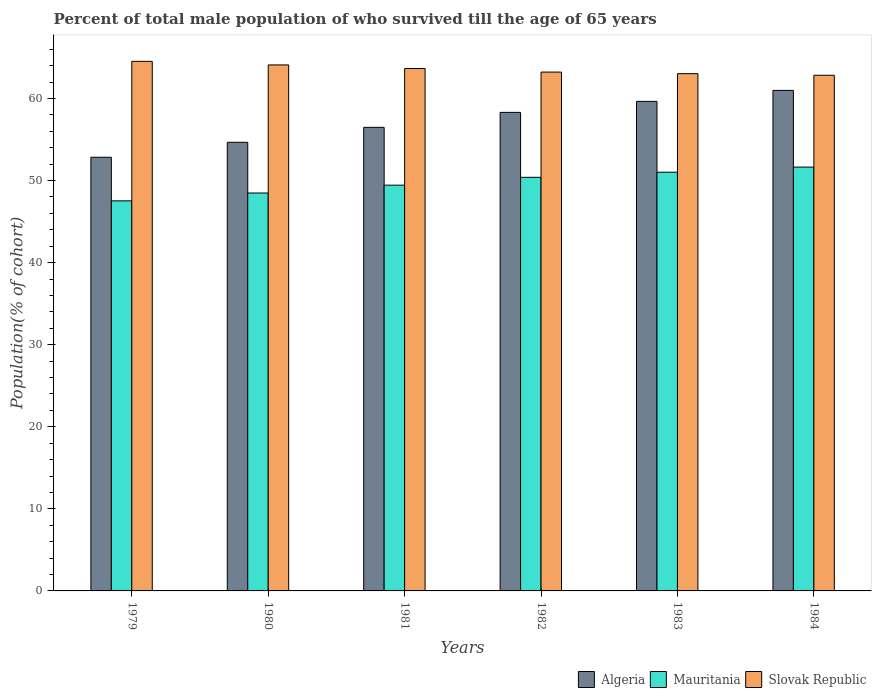How many groups of bars are there?
Your answer should be compact. 6. Are the number of bars on each tick of the X-axis equal?
Make the answer very short. Yes. How many bars are there on the 6th tick from the right?
Make the answer very short. 3. What is the label of the 2nd group of bars from the left?
Offer a terse response. 1980. In how many cases, is the number of bars for a given year not equal to the number of legend labels?
Offer a very short reply. 0. What is the percentage of total male population who survived till the age of 65 years in Algeria in 1980?
Your answer should be compact. 54.66. Across all years, what is the maximum percentage of total male population who survived till the age of 65 years in Algeria?
Ensure brevity in your answer.  60.99. Across all years, what is the minimum percentage of total male population who survived till the age of 65 years in Mauritania?
Make the answer very short. 47.53. In which year was the percentage of total male population who survived till the age of 65 years in Slovak Republic minimum?
Keep it short and to the point. 1984. What is the total percentage of total male population who survived till the age of 65 years in Mauritania in the graph?
Keep it short and to the point. 298.5. What is the difference between the percentage of total male population who survived till the age of 65 years in Mauritania in 1980 and that in 1981?
Your response must be concise. -0.96. What is the difference between the percentage of total male population who survived till the age of 65 years in Mauritania in 1982 and the percentage of total male population who survived till the age of 65 years in Slovak Republic in 1980?
Offer a terse response. -13.69. What is the average percentage of total male population who survived till the age of 65 years in Mauritania per year?
Keep it short and to the point. 49.75. In the year 1979, what is the difference between the percentage of total male population who survived till the age of 65 years in Slovak Republic and percentage of total male population who survived till the age of 65 years in Mauritania?
Your answer should be compact. 17. In how many years, is the percentage of total male population who survived till the age of 65 years in Mauritania greater than 14 %?
Provide a succinct answer. 6. What is the ratio of the percentage of total male population who survived till the age of 65 years in Algeria in 1981 to that in 1982?
Ensure brevity in your answer.  0.97. Is the percentage of total male population who survived till the age of 65 years in Algeria in 1980 less than that in 1983?
Your answer should be very brief. Yes. Is the difference between the percentage of total male population who survived till the age of 65 years in Slovak Republic in 1983 and 1984 greater than the difference between the percentage of total male population who survived till the age of 65 years in Mauritania in 1983 and 1984?
Provide a succinct answer. Yes. What is the difference between the highest and the second highest percentage of total male population who survived till the age of 65 years in Slovak Republic?
Make the answer very short. 0.44. What is the difference between the highest and the lowest percentage of total male population who survived till the age of 65 years in Slovak Republic?
Your answer should be compact. 1.69. In how many years, is the percentage of total male population who survived till the age of 65 years in Algeria greater than the average percentage of total male population who survived till the age of 65 years in Algeria taken over all years?
Make the answer very short. 3. What does the 1st bar from the left in 1983 represents?
Provide a succinct answer. Algeria. What does the 3rd bar from the right in 1982 represents?
Your answer should be compact. Algeria. How many years are there in the graph?
Your response must be concise. 6. What is the difference between two consecutive major ticks on the Y-axis?
Your answer should be compact. 10. Does the graph contain any zero values?
Keep it short and to the point. No. Does the graph contain grids?
Offer a very short reply. No. How many legend labels are there?
Make the answer very short. 3. What is the title of the graph?
Provide a succinct answer. Percent of total male population of who survived till the age of 65 years. What is the label or title of the Y-axis?
Make the answer very short. Population(% of cohort). What is the Population(% of cohort) in Algeria in 1979?
Make the answer very short. 52.84. What is the Population(% of cohort) in Mauritania in 1979?
Offer a very short reply. 47.53. What is the Population(% of cohort) in Slovak Republic in 1979?
Offer a terse response. 64.53. What is the Population(% of cohort) in Algeria in 1980?
Your answer should be very brief. 54.66. What is the Population(% of cohort) in Mauritania in 1980?
Provide a short and direct response. 48.48. What is the Population(% of cohort) of Slovak Republic in 1980?
Offer a very short reply. 64.09. What is the Population(% of cohort) of Algeria in 1981?
Offer a terse response. 56.49. What is the Population(% of cohort) in Mauritania in 1981?
Your answer should be compact. 49.44. What is the Population(% of cohort) in Slovak Republic in 1981?
Offer a terse response. 63.65. What is the Population(% of cohort) in Algeria in 1982?
Make the answer very short. 58.31. What is the Population(% of cohort) of Mauritania in 1982?
Your answer should be very brief. 50.39. What is the Population(% of cohort) of Slovak Republic in 1982?
Your response must be concise. 63.22. What is the Population(% of cohort) in Algeria in 1983?
Offer a very short reply. 59.65. What is the Population(% of cohort) in Mauritania in 1983?
Offer a very short reply. 51.02. What is the Population(% of cohort) in Slovak Republic in 1983?
Offer a very short reply. 63.03. What is the Population(% of cohort) in Algeria in 1984?
Your answer should be very brief. 60.99. What is the Population(% of cohort) of Mauritania in 1984?
Provide a succinct answer. 51.64. What is the Population(% of cohort) of Slovak Republic in 1984?
Make the answer very short. 62.83. Across all years, what is the maximum Population(% of cohort) in Algeria?
Your answer should be very brief. 60.99. Across all years, what is the maximum Population(% of cohort) in Mauritania?
Make the answer very short. 51.64. Across all years, what is the maximum Population(% of cohort) of Slovak Republic?
Keep it short and to the point. 64.53. Across all years, what is the minimum Population(% of cohort) in Algeria?
Offer a terse response. 52.84. Across all years, what is the minimum Population(% of cohort) of Mauritania?
Your response must be concise. 47.53. Across all years, what is the minimum Population(% of cohort) of Slovak Republic?
Make the answer very short. 62.83. What is the total Population(% of cohort) of Algeria in the graph?
Provide a succinct answer. 342.93. What is the total Population(% of cohort) of Mauritania in the graph?
Ensure brevity in your answer.  298.5. What is the total Population(% of cohort) in Slovak Republic in the graph?
Give a very brief answer. 381.34. What is the difference between the Population(% of cohort) in Algeria in 1979 and that in 1980?
Ensure brevity in your answer.  -1.82. What is the difference between the Population(% of cohort) in Mauritania in 1979 and that in 1980?
Your response must be concise. -0.96. What is the difference between the Population(% of cohort) in Slovak Republic in 1979 and that in 1980?
Offer a terse response. 0.44. What is the difference between the Population(% of cohort) in Algeria in 1979 and that in 1981?
Provide a short and direct response. -3.64. What is the difference between the Population(% of cohort) of Mauritania in 1979 and that in 1981?
Ensure brevity in your answer.  -1.91. What is the difference between the Population(% of cohort) of Slovak Republic in 1979 and that in 1981?
Offer a very short reply. 0.87. What is the difference between the Population(% of cohort) in Algeria in 1979 and that in 1982?
Offer a very short reply. -5.47. What is the difference between the Population(% of cohort) in Mauritania in 1979 and that in 1982?
Your answer should be compact. -2.87. What is the difference between the Population(% of cohort) of Slovak Republic in 1979 and that in 1982?
Give a very brief answer. 1.31. What is the difference between the Population(% of cohort) in Algeria in 1979 and that in 1983?
Your answer should be very brief. -6.81. What is the difference between the Population(% of cohort) of Mauritania in 1979 and that in 1983?
Your answer should be compact. -3.49. What is the difference between the Population(% of cohort) in Slovak Republic in 1979 and that in 1983?
Your answer should be compact. 1.5. What is the difference between the Population(% of cohort) of Algeria in 1979 and that in 1984?
Your answer should be compact. -8.14. What is the difference between the Population(% of cohort) of Mauritania in 1979 and that in 1984?
Provide a succinct answer. -4.11. What is the difference between the Population(% of cohort) in Slovak Republic in 1979 and that in 1984?
Keep it short and to the point. 1.69. What is the difference between the Population(% of cohort) of Algeria in 1980 and that in 1981?
Your answer should be compact. -1.82. What is the difference between the Population(% of cohort) of Mauritania in 1980 and that in 1981?
Make the answer very short. -0.96. What is the difference between the Population(% of cohort) in Slovak Republic in 1980 and that in 1981?
Provide a short and direct response. 0.44. What is the difference between the Population(% of cohort) of Algeria in 1980 and that in 1982?
Provide a succinct answer. -3.64. What is the difference between the Population(% of cohort) in Mauritania in 1980 and that in 1982?
Ensure brevity in your answer.  -1.91. What is the difference between the Population(% of cohort) in Slovak Republic in 1980 and that in 1982?
Provide a succinct answer. 0.87. What is the difference between the Population(% of cohort) of Algeria in 1980 and that in 1983?
Keep it short and to the point. -4.98. What is the difference between the Population(% of cohort) of Mauritania in 1980 and that in 1983?
Your answer should be very brief. -2.53. What is the difference between the Population(% of cohort) in Slovak Republic in 1980 and that in 1983?
Make the answer very short. 1.06. What is the difference between the Population(% of cohort) in Algeria in 1980 and that in 1984?
Offer a terse response. -6.32. What is the difference between the Population(% of cohort) in Mauritania in 1980 and that in 1984?
Make the answer very short. -3.16. What is the difference between the Population(% of cohort) of Slovak Republic in 1980 and that in 1984?
Your response must be concise. 1.26. What is the difference between the Population(% of cohort) of Algeria in 1981 and that in 1982?
Your answer should be very brief. -1.82. What is the difference between the Population(% of cohort) in Mauritania in 1981 and that in 1982?
Offer a very short reply. -0.96. What is the difference between the Population(% of cohort) in Slovak Republic in 1981 and that in 1982?
Ensure brevity in your answer.  0.44. What is the difference between the Population(% of cohort) in Algeria in 1981 and that in 1983?
Provide a short and direct response. -3.16. What is the difference between the Population(% of cohort) of Mauritania in 1981 and that in 1983?
Your answer should be compact. -1.58. What is the difference between the Population(% of cohort) of Slovak Republic in 1981 and that in 1983?
Your response must be concise. 0.63. What is the difference between the Population(% of cohort) in Mauritania in 1981 and that in 1984?
Provide a short and direct response. -2.2. What is the difference between the Population(% of cohort) of Slovak Republic in 1981 and that in 1984?
Your answer should be compact. 0.82. What is the difference between the Population(% of cohort) of Algeria in 1982 and that in 1983?
Your answer should be compact. -1.34. What is the difference between the Population(% of cohort) in Mauritania in 1982 and that in 1983?
Give a very brief answer. -0.62. What is the difference between the Population(% of cohort) in Slovak Republic in 1982 and that in 1983?
Make the answer very short. 0.19. What is the difference between the Population(% of cohort) in Algeria in 1982 and that in 1984?
Offer a terse response. -2.68. What is the difference between the Population(% of cohort) of Mauritania in 1982 and that in 1984?
Ensure brevity in your answer.  -1.25. What is the difference between the Population(% of cohort) of Slovak Republic in 1982 and that in 1984?
Offer a very short reply. 0.38. What is the difference between the Population(% of cohort) in Algeria in 1983 and that in 1984?
Your answer should be compact. -1.34. What is the difference between the Population(% of cohort) of Mauritania in 1983 and that in 1984?
Offer a very short reply. -0.62. What is the difference between the Population(% of cohort) of Slovak Republic in 1983 and that in 1984?
Your answer should be very brief. 0.19. What is the difference between the Population(% of cohort) in Algeria in 1979 and the Population(% of cohort) in Mauritania in 1980?
Your answer should be compact. 4.36. What is the difference between the Population(% of cohort) in Algeria in 1979 and the Population(% of cohort) in Slovak Republic in 1980?
Your answer should be compact. -11.25. What is the difference between the Population(% of cohort) in Mauritania in 1979 and the Population(% of cohort) in Slovak Republic in 1980?
Your answer should be compact. -16.56. What is the difference between the Population(% of cohort) of Algeria in 1979 and the Population(% of cohort) of Mauritania in 1981?
Provide a short and direct response. 3.4. What is the difference between the Population(% of cohort) of Algeria in 1979 and the Population(% of cohort) of Slovak Republic in 1981?
Your answer should be compact. -10.81. What is the difference between the Population(% of cohort) in Mauritania in 1979 and the Population(% of cohort) in Slovak Republic in 1981?
Your answer should be very brief. -16.13. What is the difference between the Population(% of cohort) of Algeria in 1979 and the Population(% of cohort) of Mauritania in 1982?
Offer a very short reply. 2.45. What is the difference between the Population(% of cohort) of Algeria in 1979 and the Population(% of cohort) of Slovak Republic in 1982?
Your answer should be compact. -10.38. What is the difference between the Population(% of cohort) in Mauritania in 1979 and the Population(% of cohort) in Slovak Republic in 1982?
Keep it short and to the point. -15.69. What is the difference between the Population(% of cohort) of Algeria in 1979 and the Population(% of cohort) of Mauritania in 1983?
Ensure brevity in your answer.  1.82. What is the difference between the Population(% of cohort) of Algeria in 1979 and the Population(% of cohort) of Slovak Republic in 1983?
Provide a succinct answer. -10.18. What is the difference between the Population(% of cohort) of Mauritania in 1979 and the Population(% of cohort) of Slovak Republic in 1983?
Provide a succinct answer. -15.5. What is the difference between the Population(% of cohort) of Algeria in 1979 and the Population(% of cohort) of Mauritania in 1984?
Offer a very short reply. 1.2. What is the difference between the Population(% of cohort) in Algeria in 1979 and the Population(% of cohort) in Slovak Republic in 1984?
Offer a terse response. -9.99. What is the difference between the Population(% of cohort) of Mauritania in 1979 and the Population(% of cohort) of Slovak Republic in 1984?
Keep it short and to the point. -15.31. What is the difference between the Population(% of cohort) in Algeria in 1980 and the Population(% of cohort) in Mauritania in 1981?
Provide a succinct answer. 5.22. What is the difference between the Population(% of cohort) of Algeria in 1980 and the Population(% of cohort) of Slovak Republic in 1981?
Ensure brevity in your answer.  -8.99. What is the difference between the Population(% of cohort) of Mauritania in 1980 and the Population(% of cohort) of Slovak Republic in 1981?
Offer a very short reply. -15.17. What is the difference between the Population(% of cohort) in Algeria in 1980 and the Population(% of cohort) in Mauritania in 1982?
Give a very brief answer. 4.27. What is the difference between the Population(% of cohort) of Algeria in 1980 and the Population(% of cohort) of Slovak Republic in 1982?
Your answer should be very brief. -8.55. What is the difference between the Population(% of cohort) in Mauritania in 1980 and the Population(% of cohort) in Slovak Republic in 1982?
Offer a very short reply. -14.73. What is the difference between the Population(% of cohort) of Algeria in 1980 and the Population(% of cohort) of Mauritania in 1983?
Keep it short and to the point. 3.65. What is the difference between the Population(% of cohort) in Algeria in 1980 and the Population(% of cohort) in Slovak Republic in 1983?
Give a very brief answer. -8.36. What is the difference between the Population(% of cohort) of Mauritania in 1980 and the Population(% of cohort) of Slovak Republic in 1983?
Your answer should be very brief. -14.54. What is the difference between the Population(% of cohort) in Algeria in 1980 and the Population(% of cohort) in Mauritania in 1984?
Make the answer very short. 3.02. What is the difference between the Population(% of cohort) of Algeria in 1980 and the Population(% of cohort) of Slovak Republic in 1984?
Provide a short and direct response. -8.17. What is the difference between the Population(% of cohort) in Mauritania in 1980 and the Population(% of cohort) in Slovak Republic in 1984?
Ensure brevity in your answer.  -14.35. What is the difference between the Population(% of cohort) of Algeria in 1981 and the Population(% of cohort) of Mauritania in 1982?
Your response must be concise. 6.09. What is the difference between the Population(% of cohort) of Algeria in 1981 and the Population(% of cohort) of Slovak Republic in 1982?
Offer a terse response. -6.73. What is the difference between the Population(% of cohort) of Mauritania in 1981 and the Population(% of cohort) of Slovak Republic in 1982?
Ensure brevity in your answer.  -13.78. What is the difference between the Population(% of cohort) in Algeria in 1981 and the Population(% of cohort) in Mauritania in 1983?
Provide a short and direct response. 5.47. What is the difference between the Population(% of cohort) in Algeria in 1981 and the Population(% of cohort) in Slovak Republic in 1983?
Offer a very short reply. -6.54. What is the difference between the Population(% of cohort) of Mauritania in 1981 and the Population(% of cohort) of Slovak Republic in 1983?
Offer a terse response. -13.59. What is the difference between the Population(% of cohort) in Algeria in 1981 and the Population(% of cohort) in Mauritania in 1984?
Make the answer very short. 4.84. What is the difference between the Population(% of cohort) in Algeria in 1981 and the Population(% of cohort) in Slovak Republic in 1984?
Offer a terse response. -6.35. What is the difference between the Population(% of cohort) in Mauritania in 1981 and the Population(% of cohort) in Slovak Republic in 1984?
Make the answer very short. -13.39. What is the difference between the Population(% of cohort) of Algeria in 1982 and the Population(% of cohort) of Mauritania in 1983?
Your response must be concise. 7.29. What is the difference between the Population(% of cohort) of Algeria in 1982 and the Population(% of cohort) of Slovak Republic in 1983?
Make the answer very short. -4.72. What is the difference between the Population(% of cohort) of Mauritania in 1982 and the Population(% of cohort) of Slovak Republic in 1983?
Your response must be concise. -12.63. What is the difference between the Population(% of cohort) of Algeria in 1982 and the Population(% of cohort) of Mauritania in 1984?
Your answer should be very brief. 6.67. What is the difference between the Population(% of cohort) in Algeria in 1982 and the Population(% of cohort) in Slovak Republic in 1984?
Offer a terse response. -4.53. What is the difference between the Population(% of cohort) of Mauritania in 1982 and the Population(% of cohort) of Slovak Republic in 1984?
Your answer should be compact. -12.44. What is the difference between the Population(% of cohort) in Algeria in 1983 and the Population(% of cohort) in Mauritania in 1984?
Provide a succinct answer. 8.01. What is the difference between the Population(% of cohort) in Algeria in 1983 and the Population(% of cohort) in Slovak Republic in 1984?
Keep it short and to the point. -3.19. What is the difference between the Population(% of cohort) of Mauritania in 1983 and the Population(% of cohort) of Slovak Republic in 1984?
Your response must be concise. -11.82. What is the average Population(% of cohort) of Algeria per year?
Provide a succinct answer. 57.16. What is the average Population(% of cohort) of Mauritania per year?
Your response must be concise. 49.75. What is the average Population(% of cohort) in Slovak Republic per year?
Your answer should be very brief. 63.56. In the year 1979, what is the difference between the Population(% of cohort) in Algeria and Population(% of cohort) in Mauritania?
Keep it short and to the point. 5.31. In the year 1979, what is the difference between the Population(% of cohort) of Algeria and Population(% of cohort) of Slovak Republic?
Give a very brief answer. -11.68. In the year 1979, what is the difference between the Population(% of cohort) in Mauritania and Population(% of cohort) in Slovak Republic?
Keep it short and to the point. -17. In the year 1980, what is the difference between the Population(% of cohort) of Algeria and Population(% of cohort) of Mauritania?
Your response must be concise. 6.18. In the year 1980, what is the difference between the Population(% of cohort) of Algeria and Population(% of cohort) of Slovak Republic?
Make the answer very short. -9.43. In the year 1980, what is the difference between the Population(% of cohort) of Mauritania and Population(% of cohort) of Slovak Republic?
Your answer should be compact. -15.61. In the year 1981, what is the difference between the Population(% of cohort) of Algeria and Population(% of cohort) of Mauritania?
Provide a short and direct response. 7.05. In the year 1981, what is the difference between the Population(% of cohort) in Algeria and Population(% of cohort) in Slovak Republic?
Your answer should be compact. -7.17. In the year 1981, what is the difference between the Population(% of cohort) of Mauritania and Population(% of cohort) of Slovak Republic?
Your response must be concise. -14.21. In the year 1982, what is the difference between the Population(% of cohort) of Algeria and Population(% of cohort) of Mauritania?
Offer a terse response. 7.91. In the year 1982, what is the difference between the Population(% of cohort) in Algeria and Population(% of cohort) in Slovak Republic?
Offer a very short reply. -4.91. In the year 1982, what is the difference between the Population(% of cohort) of Mauritania and Population(% of cohort) of Slovak Republic?
Offer a very short reply. -12.82. In the year 1983, what is the difference between the Population(% of cohort) of Algeria and Population(% of cohort) of Mauritania?
Provide a short and direct response. 8.63. In the year 1983, what is the difference between the Population(% of cohort) of Algeria and Population(% of cohort) of Slovak Republic?
Your response must be concise. -3.38. In the year 1983, what is the difference between the Population(% of cohort) of Mauritania and Population(% of cohort) of Slovak Republic?
Your answer should be very brief. -12.01. In the year 1984, what is the difference between the Population(% of cohort) in Algeria and Population(% of cohort) in Mauritania?
Your answer should be very brief. 9.34. In the year 1984, what is the difference between the Population(% of cohort) in Algeria and Population(% of cohort) in Slovak Republic?
Give a very brief answer. -1.85. In the year 1984, what is the difference between the Population(% of cohort) of Mauritania and Population(% of cohort) of Slovak Republic?
Provide a short and direct response. -11.19. What is the ratio of the Population(% of cohort) of Algeria in 1979 to that in 1980?
Ensure brevity in your answer.  0.97. What is the ratio of the Population(% of cohort) of Mauritania in 1979 to that in 1980?
Keep it short and to the point. 0.98. What is the ratio of the Population(% of cohort) of Slovak Republic in 1979 to that in 1980?
Your answer should be very brief. 1.01. What is the ratio of the Population(% of cohort) in Algeria in 1979 to that in 1981?
Provide a short and direct response. 0.94. What is the ratio of the Population(% of cohort) of Mauritania in 1979 to that in 1981?
Give a very brief answer. 0.96. What is the ratio of the Population(% of cohort) in Slovak Republic in 1979 to that in 1981?
Provide a short and direct response. 1.01. What is the ratio of the Population(% of cohort) of Algeria in 1979 to that in 1982?
Make the answer very short. 0.91. What is the ratio of the Population(% of cohort) in Mauritania in 1979 to that in 1982?
Keep it short and to the point. 0.94. What is the ratio of the Population(% of cohort) in Slovak Republic in 1979 to that in 1982?
Your response must be concise. 1.02. What is the ratio of the Population(% of cohort) in Algeria in 1979 to that in 1983?
Provide a succinct answer. 0.89. What is the ratio of the Population(% of cohort) in Mauritania in 1979 to that in 1983?
Offer a terse response. 0.93. What is the ratio of the Population(% of cohort) of Slovak Republic in 1979 to that in 1983?
Provide a succinct answer. 1.02. What is the ratio of the Population(% of cohort) of Algeria in 1979 to that in 1984?
Ensure brevity in your answer.  0.87. What is the ratio of the Population(% of cohort) in Mauritania in 1979 to that in 1984?
Give a very brief answer. 0.92. What is the ratio of the Population(% of cohort) in Slovak Republic in 1979 to that in 1984?
Your answer should be compact. 1.03. What is the ratio of the Population(% of cohort) of Algeria in 1980 to that in 1981?
Provide a short and direct response. 0.97. What is the ratio of the Population(% of cohort) in Mauritania in 1980 to that in 1981?
Your answer should be compact. 0.98. What is the ratio of the Population(% of cohort) of Slovak Republic in 1980 to that in 1981?
Keep it short and to the point. 1.01. What is the ratio of the Population(% of cohort) in Algeria in 1980 to that in 1982?
Your answer should be compact. 0.94. What is the ratio of the Population(% of cohort) in Mauritania in 1980 to that in 1982?
Offer a terse response. 0.96. What is the ratio of the Population(% of cohort) in Slovak Republic in 1980 to that in 1982?
Your answer should be compact. 1.01. What is the ratio of the Population(% of cohort) of Algeria in 1980 to that in 1983?
Your answer should be very brief. 0.92. What is the ratio of the Population(% of cohort) in Mauritania in 1980 to that in 1983?
Provide a succinct answer. 0.95. What is the ratio of the Population(% of cohort) of Slovak Republic in 1980 to that in 1983?
Make the answer very short. 1.02. What is the ratio of the Population(% of cohort) in Algeria in 1980 to that in 1984?
Provide a succinct answer. 0.9. What is the ratio of the Population(% of cohort) in Mauritania in 1980 to that in 1984?
Ensure brevity in your answer.  0.94. What is the ratio of the Population(% of cohort) of Slovak Republic in 1980 to that in 1984?
Provide a short and direct response. 1.02. What is the ratio of the Population(% of cohort) of Algeria in 1981 to that in 1982?
Give a very brief answer. 0.97. What is the ratio of the Population(% of cohort) of Mauritania in 1981 to that in 1982?
Ensure brevity in your answer.  0.98. What is the ratio of the Population(% of cohort) of Slovak Republic in 1981 to that in 1982?
Make the answer very short. 1.01. What is the ratio of the Population(% of cohort) in Algeria in 1981 to that in 1983?
Your answer should be very brief. 0.95. What is the ratio of the Population(% of cohort) in Mauritania in 1981 to that in 1983?
Provide a succinct answer. 0.97. What is the ratio of the Population(% of cohort) of Slovak Republic in 1981 to that in 1983?
Give a very brief answer. 1.01. What is the ratio of the Population(% of cohort) of Algeria in 1981 to that in 1984?
Offer a terse response. 0.93. What is the ratio of the Population(% of cohort) of Mauritania in 1981 to that in 1984?
Give a very brief answer. 0.96. What is the ratio of the Population(% of cohort) of Algeria in 1982 to that in 1983?
Offer a very short reply. 0.98. What is the ratio of the Population(% of cohort) in Mauritania in 1982 to that in 1983?
Offer a very short reply. 0.99. What is the ratio of the Population(% of cohort) of Slovak Republic in 1982 to that in 1983?
Keep it short and to the point. 1. What is the ratio of the Population(% of cohort) of Algeria in 1982 to that in 1984?
Your answer should be very brief. 0.96. What is the ratio of the Population(% of cohort) in Mauritania in 1982 to that in 1984?
Your answer should be very brief. 0.98. What is the ratio of the Population(% of cohort) in Slovak Republic in 1982 to that in 1984?
Offer a terse response. 1.01. What is the ratio of the Population(% of cohort) in Mauritania in 1983 to that in 1984?
Make the answer very short. 0.99. What is the ratio of the Population(% of cohort) of Slovak Republic in 1983 to that in 1984?
Provide a short and direct response. 1. What is the difference between the highest and the second highest Population(% of cohort) of Algeria?
Provide a succinct answer. 1.34. What is the difference between the highest and the second highest Population(% of cohort) of Mauritania?
Provide a short and direct response. 0.62. What is the difference between the highest and the second highest Population(% of cohort) of Slovak Republic?
Provide a short and direct response. 0.44. What is the difference between the highest and the lowest Population(% of cohort) in Algeria?
Offer a very short reply. 8.14. What is the difference between the highest and the lowest Population(% of cohort) in Mauritania?
Your response must be concise. 4.11. What is the difference between the highest and the lowest Population(% of cohort) in Slovak Republic?
Your answer should be compact. 1.69. 